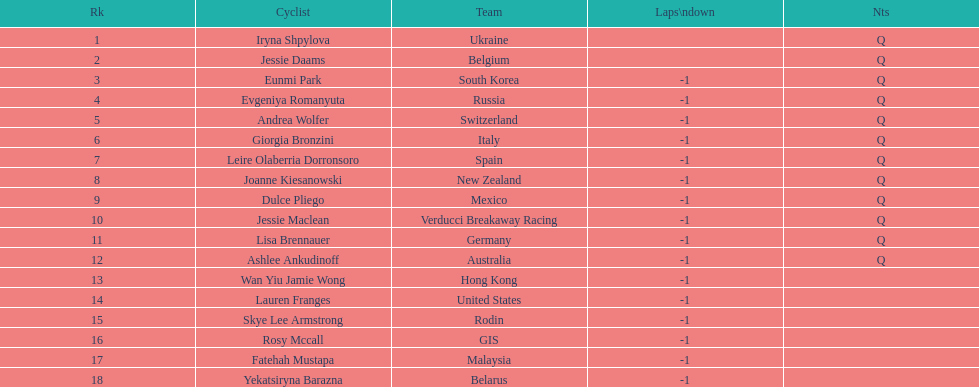How many successive notes are there? 12. 